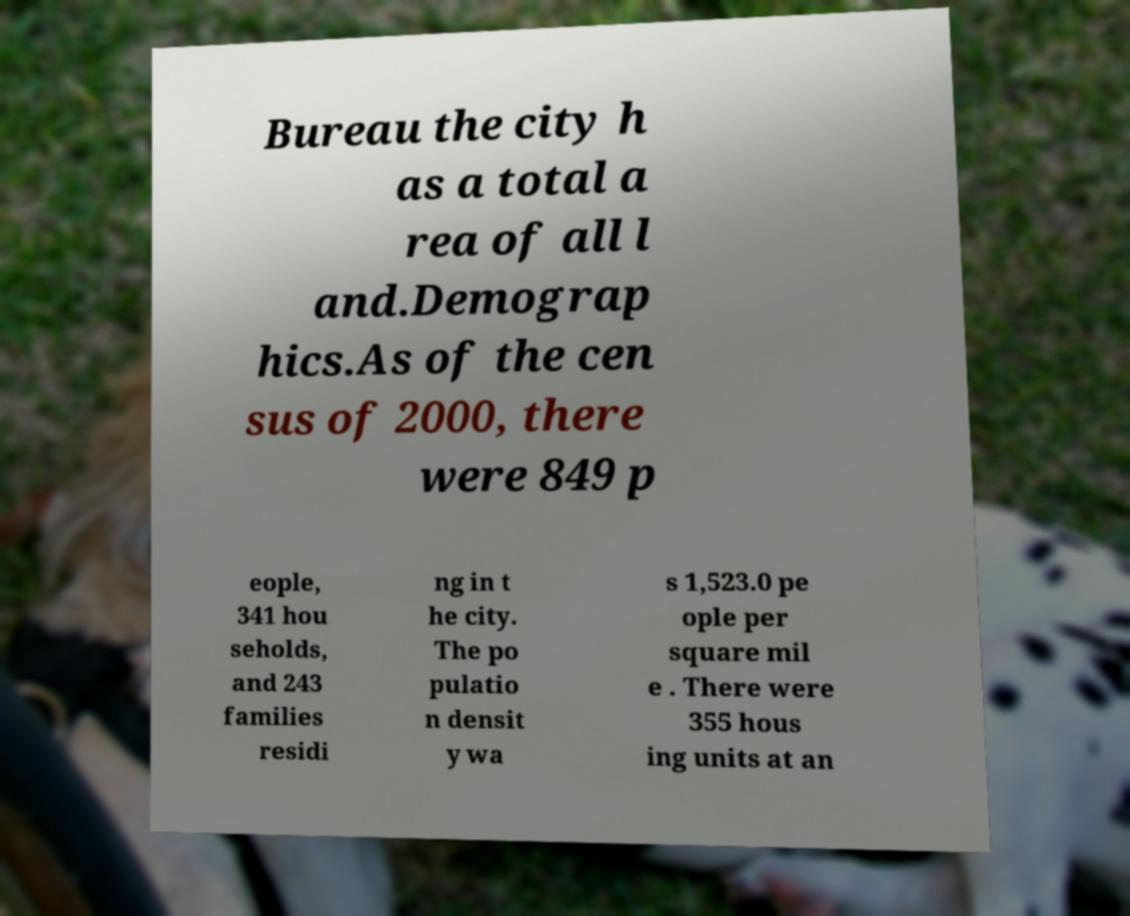I need the written content from this picture converted into text. Can you do that? Bureau the city h as a total a rea of all l and.Demograp hics.As of the cen sus of 2000, there were 849 p eople, 341 hou seholds, and 243 families residi ng in t he city. The po pulatio n densit y wa s 1,523.0 pe ople per square mil e . There were 355 hous ing units at an 